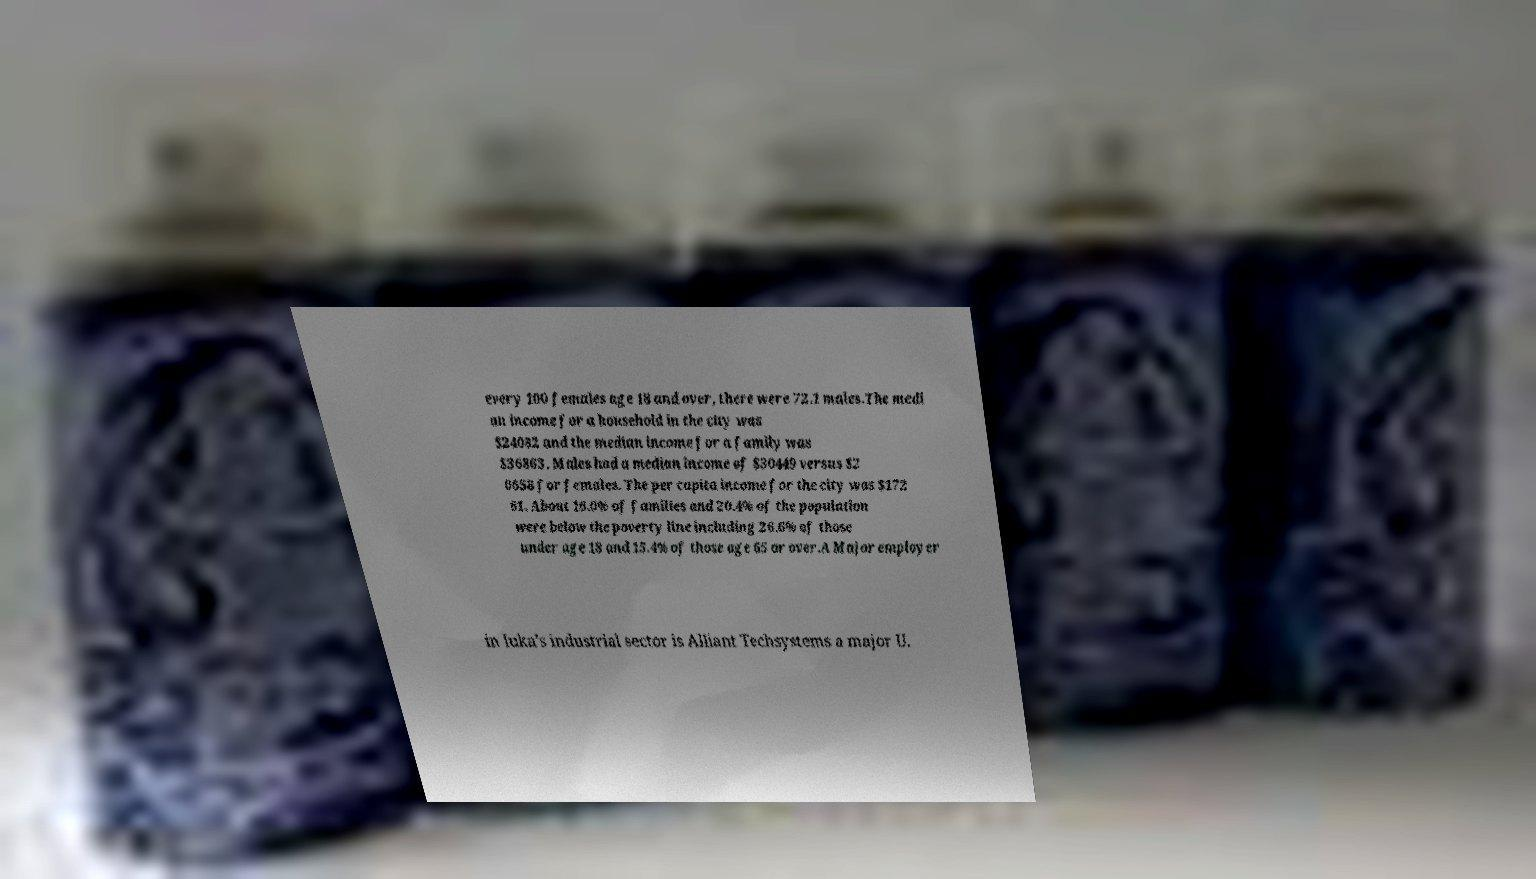There's text embedded in this image that I need extracted. Can you transcribe it verbatim? every 100 females age 18 and over, there were 72.1 males.The medi an income for a household in the city was $24082 and the median income for a family was $36863. Males had a median income of $30449 versus $2 0658 for females. The per capita income for the city was $172 61. About 16.0% of families and 20.4% of the population were below the poverty line including 26.6% of those under age 18 and 15.4% of those age 65 or over.A Major employer in Iuka's industrial sector is Alliant Techsystems a major U. 